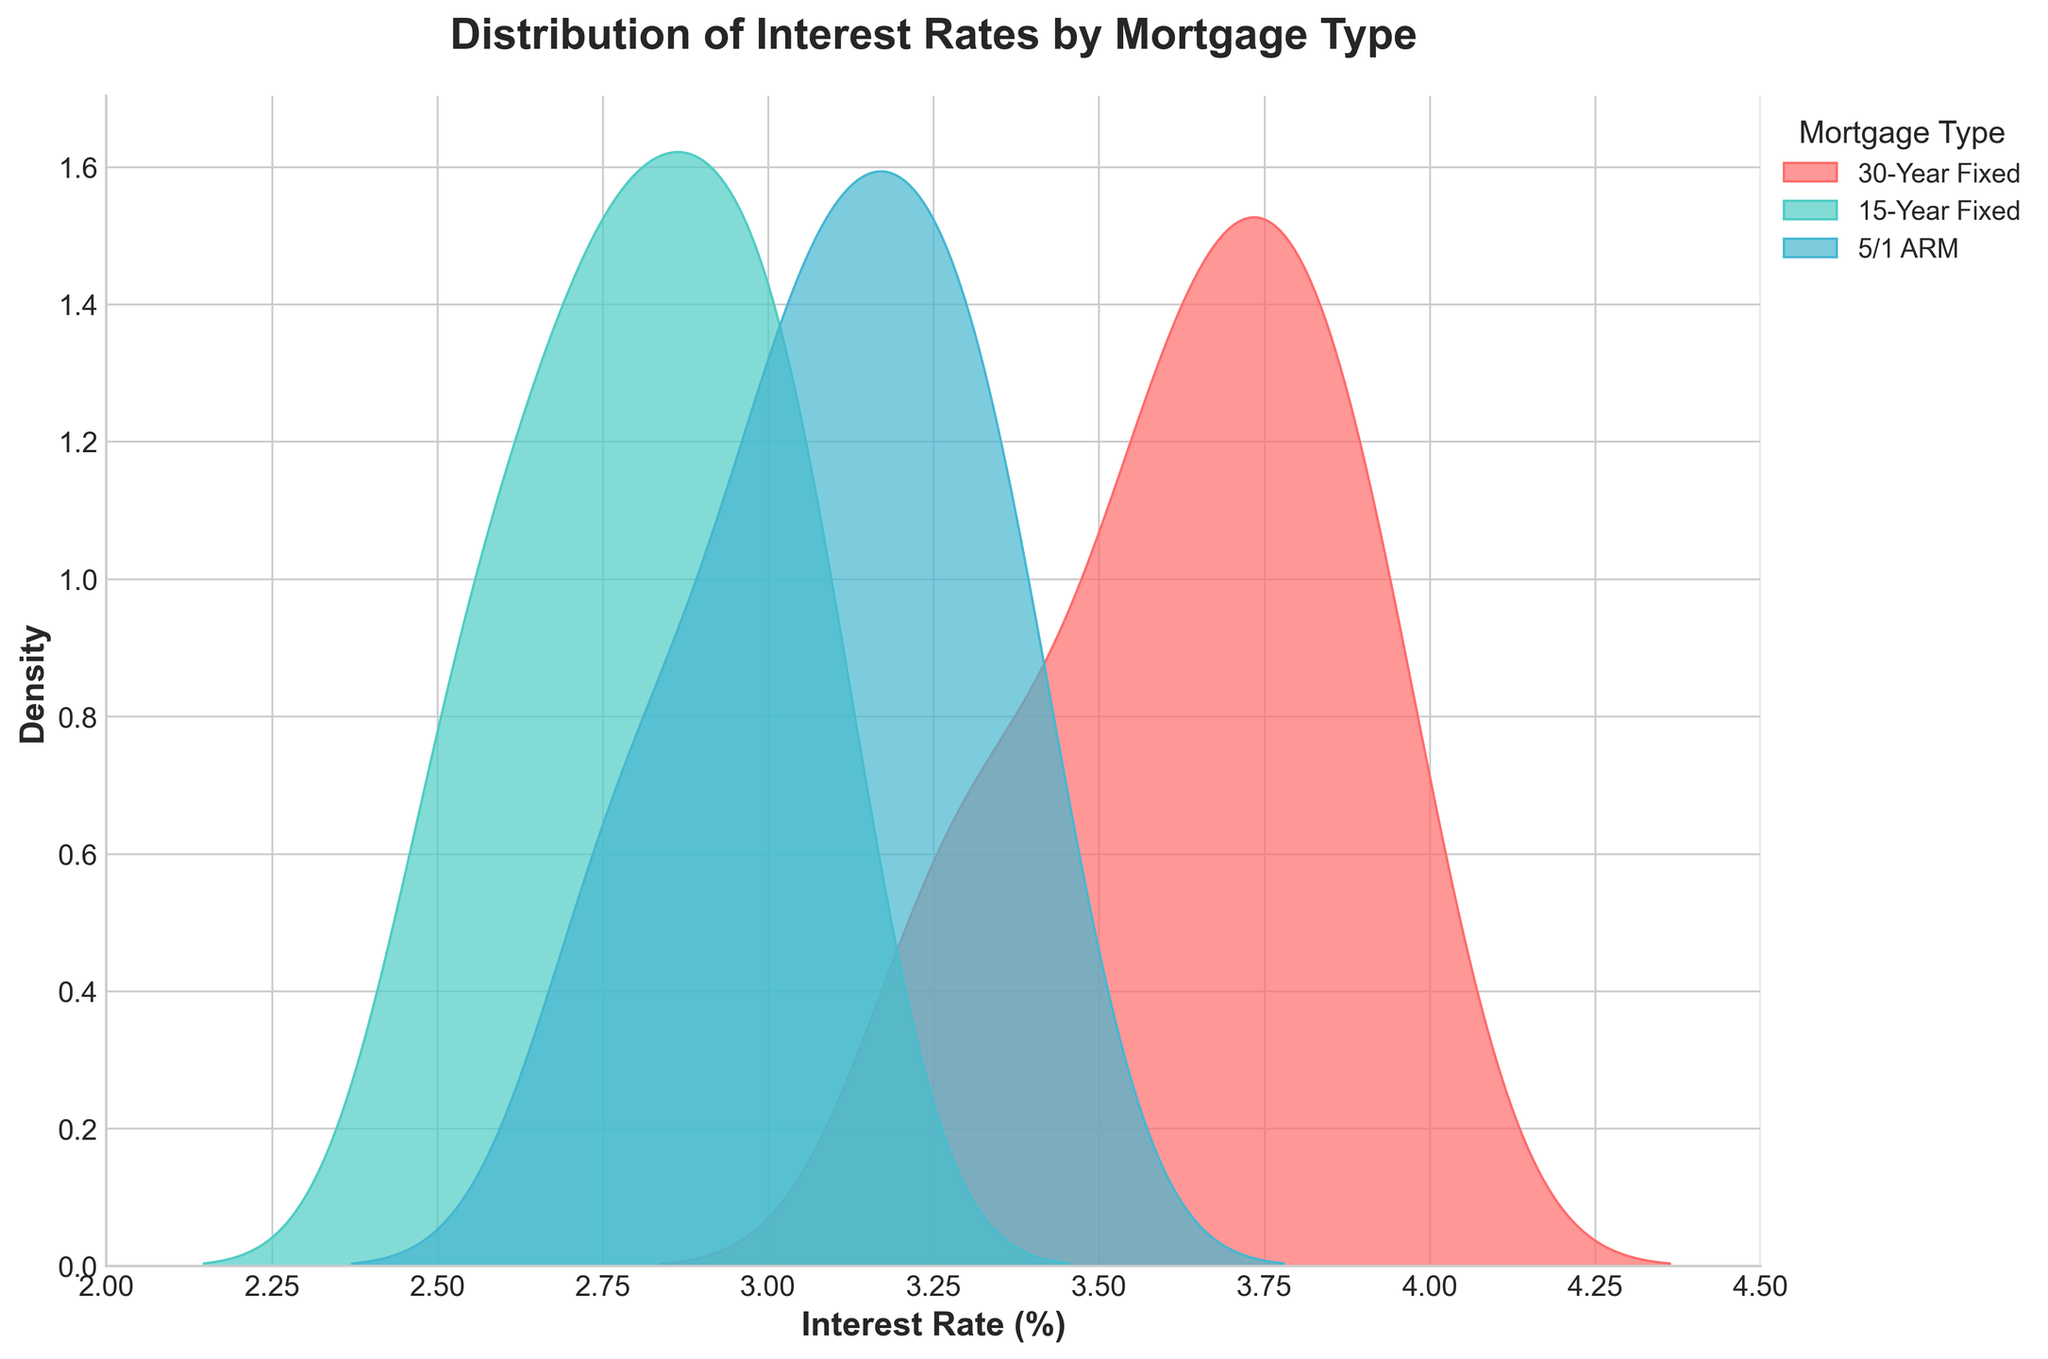What is the title of the plot? The title of the plot is clearly indicated at the top in bold font. It says "Distribution of Interest Rates by Mortgage Type."
Answer: Distribution of Interest Rates by Mortgage Type What are the three mortgage types displayed in the plot? The plot legend lists the three mortgage types represented. They are 30-Year Fixed, 15-Year Fixed, and 5/1 ARM.
Answer: 30-Year Fixed, 15-Year Fixed, 5/1 ARM Which mortgage type shows the highest peak density in the plot? By examining the peaks of the density curves, the 30-Year Fixed mortgage type has the highest peak density.
Answer: 30-Year Fixed Which mortgage type generally shows the lowest interest rates in the distribution? By observing the spread of the density plots, the 15-Year Fixed mortgage type shows interest rates generally lower than the other two types.
Answer: 15-Year Fixed What is the range of interest rates displayed on the x-axis? The x-axis ranges from 2.0% to 4.5%, as shown in the plot.
Answer: 2.0% to 4.5% How do the peak densities of the 30-Year Fixed and 5/1 ARM compare? The peak density for the 30-Year Fixed is higher than that of the 5/1 ARM, which can be observed by comparing their highest points in the plot.
Answer: 30-Year Fixed is higher Do any of the mortgage types overlap in their distributions? Yes, there is an overlap in the density curves of the mortgage types, indicating that some interest rates are common across multiple mortgage types.
Answer: Yes Which mortgage type covers the widest range of interest rates in the distribution? Looking at the density curves, the 30-Year Fixed mortgage type covers the widest range, spreading from about 3.2% to 4.0%.
Answer: 30-Year Fixed What is the color of the density curve for the 15-Year Fixed mortgage type? The density curve for the 15-Year Fixed mortgage type is light green, as indicated in the legend.
Answer: Light green What's the general trend of interest rates for 5/1 ARM compared to the 30-Year Fixed? The 5/1 ARM generally has lower interest rates, with its distribution curve shifted slightly to the left compared to the 30-Year Fixed.
Answer: Generally lower 